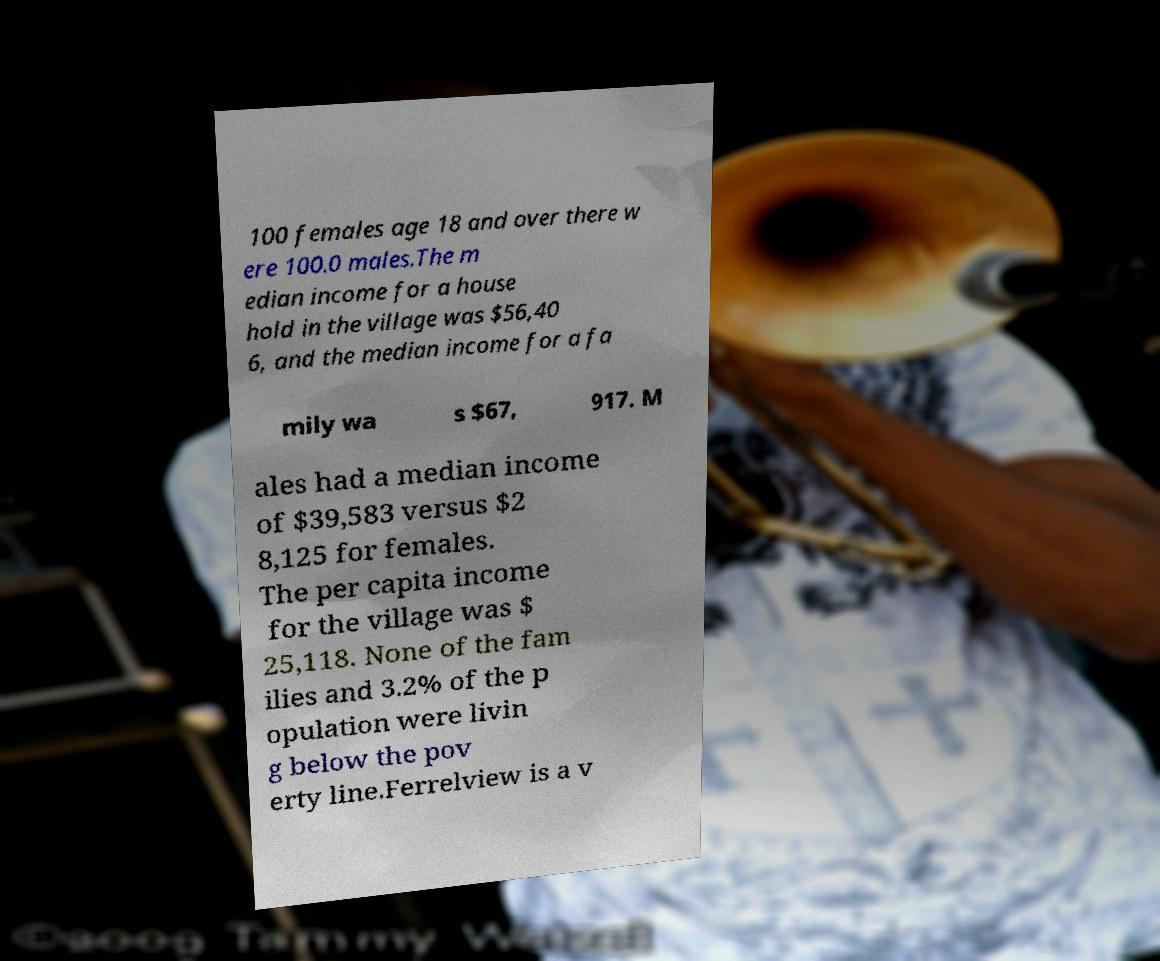Please identify and transcribe the text found in this image. 100 females age 18 and over there w ere 100.0 males.The m edian income for a house hold in the village was $56,40 6, and the median income for a fa mily wa s $67, 917. M ales had a median income of $39,583 versus $2 8,125 for females. The per capita income for the village was $ 25,118. None of the fam ilies and 3.2% of the p opulation were livin g below the pov erty line.Ferrelview is a v 